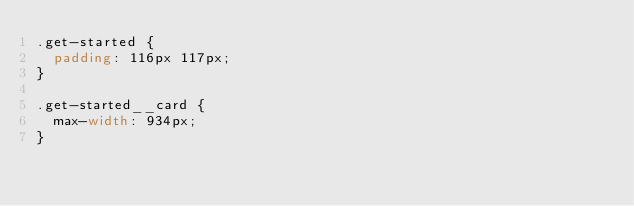Convert code to text. <code><loc_0><loc_0><loc_500><loc_500><_CSS_>.get-started {
  padding: 116px 117px;
}

.get-started__card {
  max-width: 934px;
}
</code> 